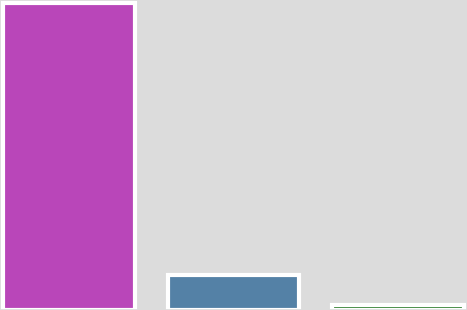Convert chart to OTSL. <chart><loc_0><loc_0><loc_500><loc_500><bar_chart><fcel>Customer relationship<fcel>Customer inducements(1)<fcel>Data center lease-based<nl><fcel>1.30883e+06<fcel>147687<fcel>18671<nl></chart> 